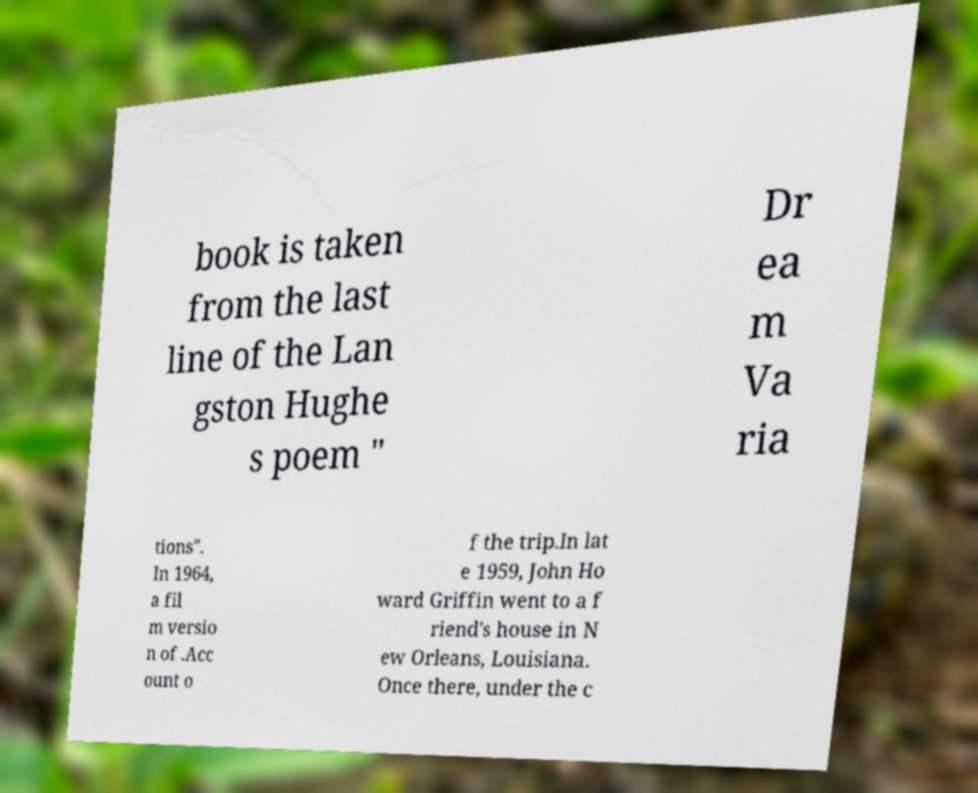Can you read and provide the text displayed in the image?This photo seems to have some interesting text. Can you extract and type it out for me? book is taken from the last line of the Lan gston Hughe s poem " Dr ea m Va ria tions". In 1964, a fil m versio n of .Acc ount o f the trip.In lat e 1959, John Ho ward Griffin went to a f riend's house in N ew Orleans, Louisiana. Once there, under the c 